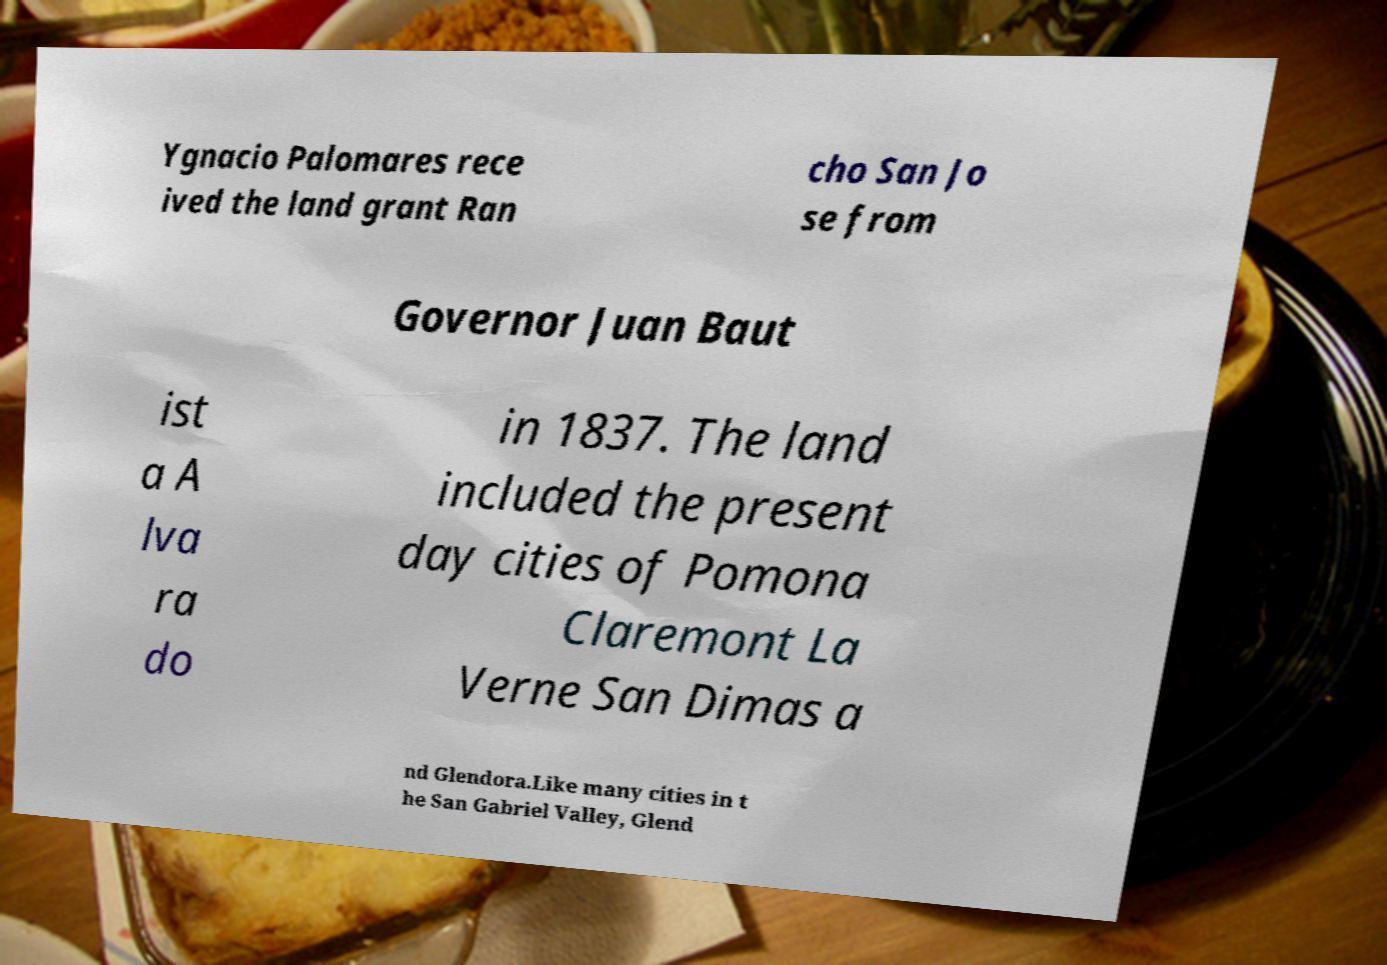What messages or text are displayed in this image? I need them in a readable, typed format. Ygnacio Palomares rece ived the land grant Ran cho San Jo se from Governor Juan Baut ist a A lva ra do in 1837. The land included the present day cities of Pomona Claremont La Verne San Dimas a nd Glendora.Like many cities in t he San Gabriel Valley, Glend 